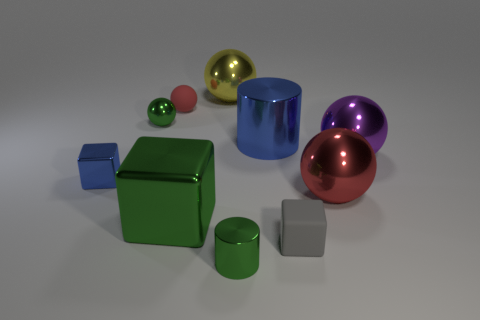Subtract all blue shiny cubes. How many cubes are left? 2 Subtract all blue blocks. How many blocks are left? 2 Subtract all cylinders. How many objects are left? 8 Subtract 2 spheres. How many spheres are left? 3 Add 7 red spheres. How many red spheres exist? 9 Subtract 1 green balls. How many objects are left? 9 Subtract all green cubes. Subtract all cyan balls. How many cubes are left? 2 Subtract all cyan blocks. How many blue cylinders are left? 1 Subtract all red matte balls. Subtract all green shiny things. How many objects are left? 6 Add 2 small green metallic cylinders. How many small green metallic cylinders are left? 3 